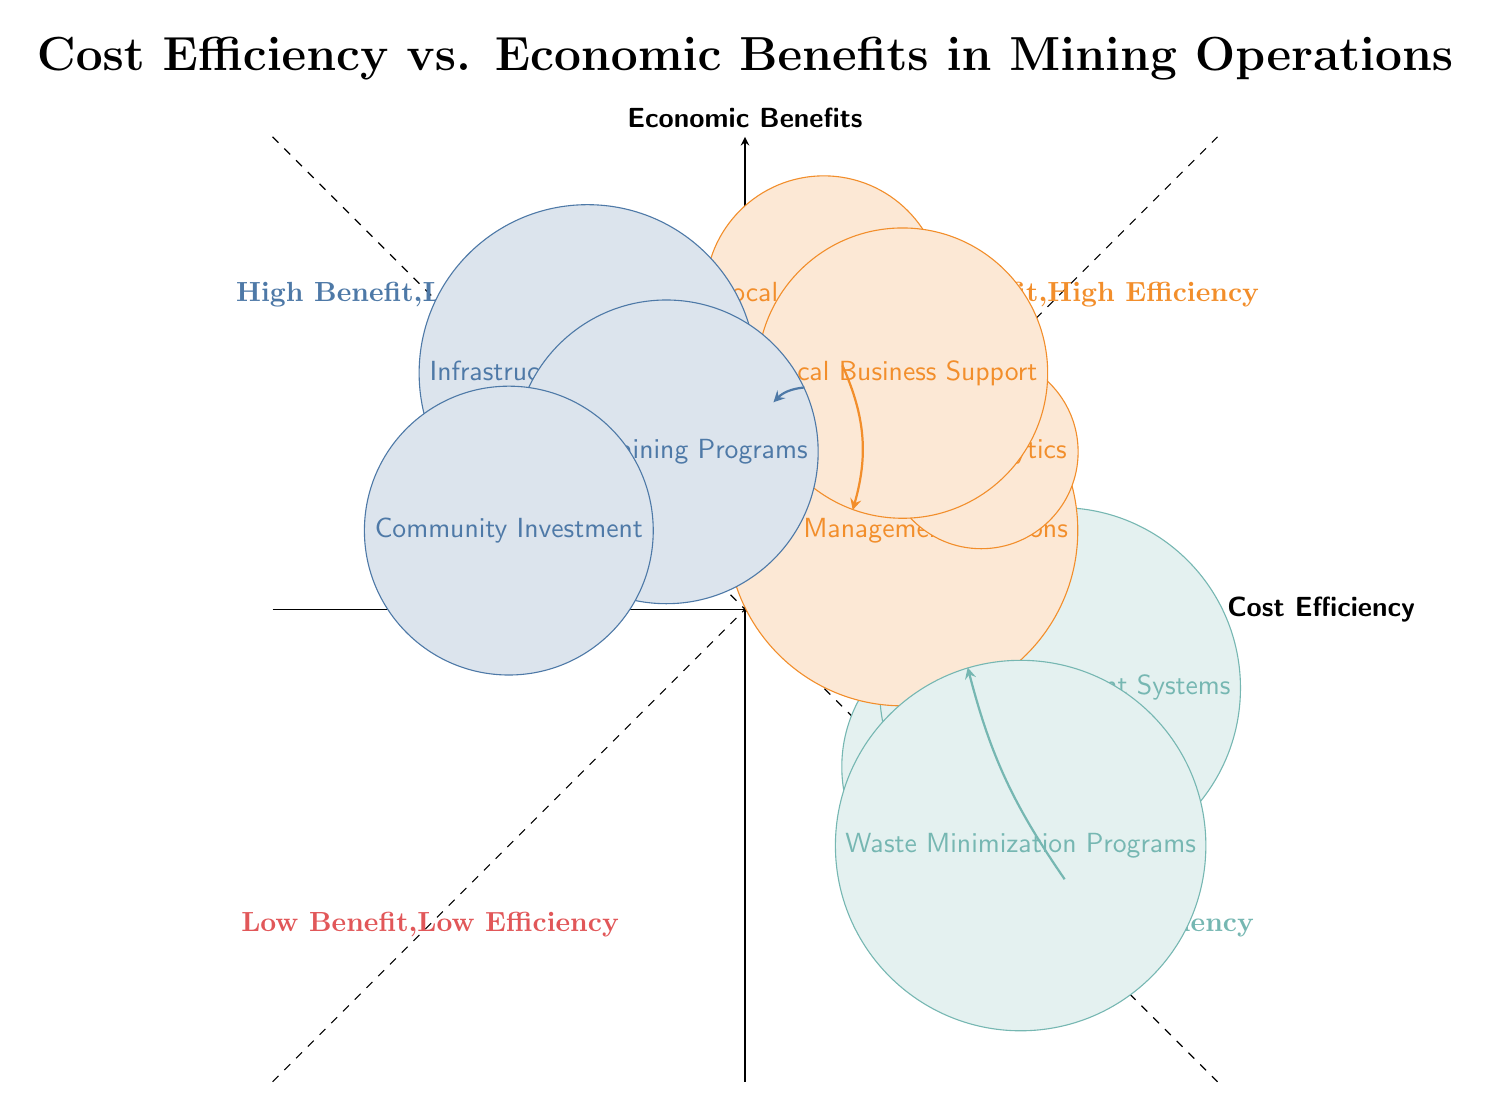What is the position of "Automated Machinery" in the diagram? "Automated Machinery" is located in the fourth quadrant, indicating high efficiency and low benefit, specifically at the coordinates (3,-2).
Answer: Fourth quadrant How many entities focus on "High Benefit, High Efficiency"? There are three entities that fall into the "High Benefit, High Efficiency" quadrant, which can be counted directly from the data points in that quadrant.
Answer: Three Which two nodes have a direct connection? The nodes "Fleet Management Solutions" and "Local Business Support" have a direct connection, indicated by the curved arrow pointing from the former to the latter.
Answer: Fleet Management Solutions and Local Business Support What does "Local Employment" represent in terms of benefit? "Local Employment" represents a high economic benefit as it is situated in the second quadrant where both cost efficiency and economic benefits are high.
Answer: High economic benefit Which node is closest to the origin in the diagram? The node that is closest to the origin (0,0) is "Automated Machinery," located at (3,-2), making it the nearest among the entities.
Answer: Automated Machinery What relationship exists between "Skills Training Programs" and "Local Employment"? The relationship is that "Skills Training Programs" lead to improvement in "Local Employment," as indicated by the curved arrow showing movement from the former to the latter.
Answer: Positive relationship How many entities focus on low economic benefit and high efficiency? There are four entities in the fourth quadrant that focus on low economic benefit and high efficiency, which is evident by counting the nodes in that specific quadrant.
Answer: Four Which program is connected to "Community Investment"? The node "Skills Training Programs" connects to "Community Investment," implying that improving skills may support community initiatives.
Answer: Skills Training Programs 